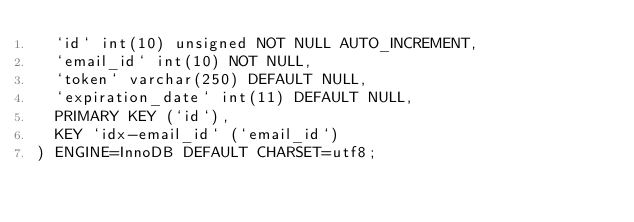Convert code to text. <code><loc_0><loc_0><loc_500><loc_500><_SQL_>  `id` int(10) unsigned NOT NULL AUTO_INCREMENT,
  `email_id` int(10) NOT NULL,
  `token` varchar(250) DEFAULT NULL,
  `expiration_date` int(11) DEFAULT NULL,
  PRIMARY KEY (`id`),
  KEY `idx-email_id` (`email_id`)
) ENGINE=InnoDB DEFAULT CHARSET=utf8;

</code> 